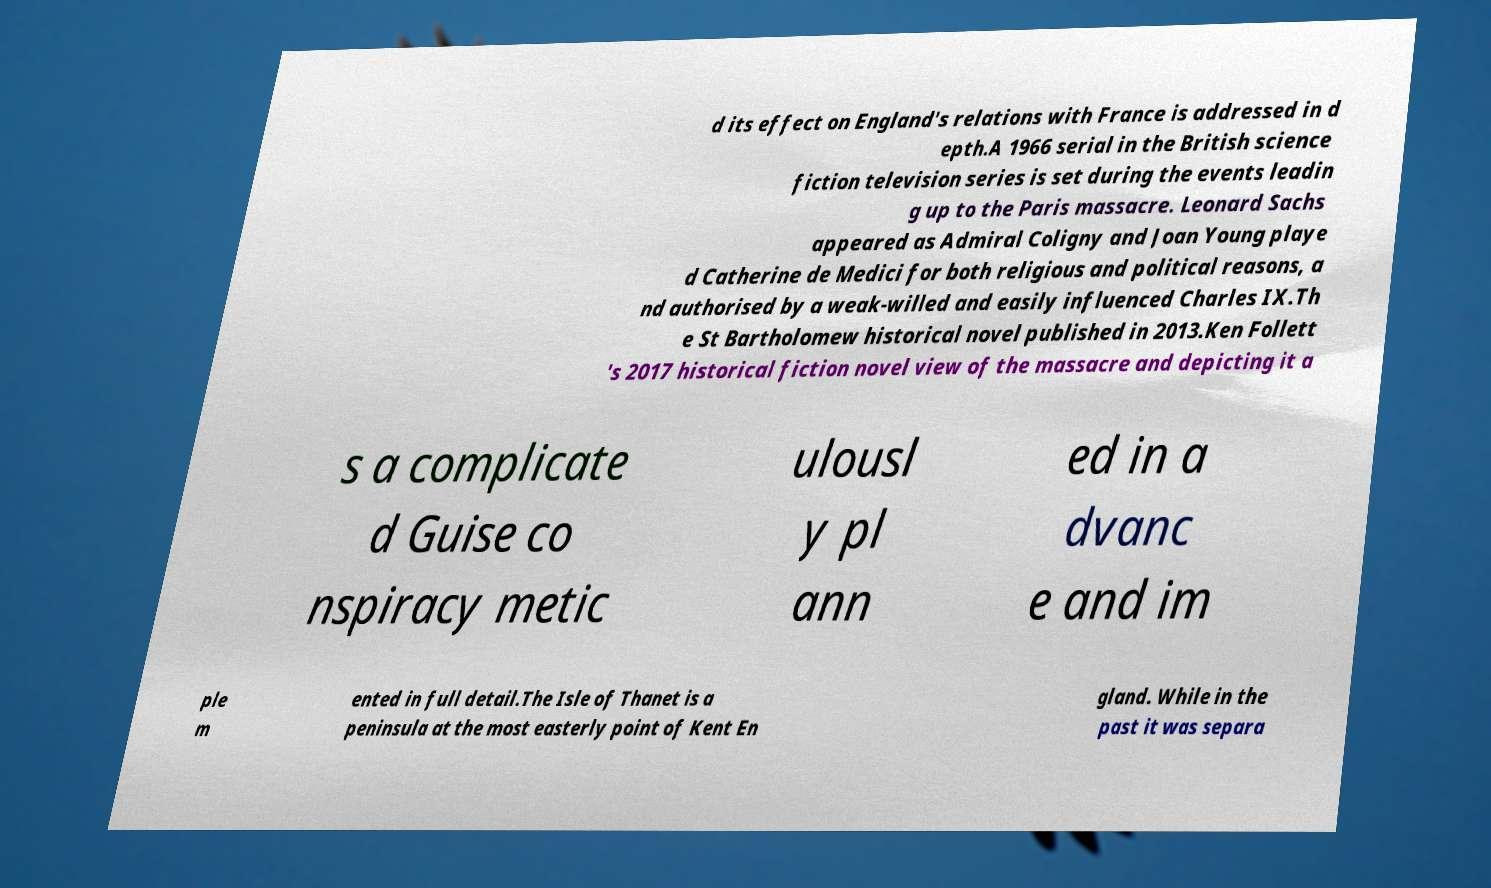There's text embedded in this image that I need extracted. Can you transcribe it verbatim? d its effect on England's relations with France is addressed in d epth.A 1966 serial in the British science fiction television series is set during the events leadin g up to the Paris massacre. Leonard Sachs appeared as Admiral Coligny and Joan Young playe d Catherine de Medici for both religious and political reasons, a nd authorised by a weak-willed and easily influenced Charles IX.Th e St Bartholomew historical novel published in 2013.Ken Follett 's 2017 historical fiction novel view of the massacre and depicting it a s a complicate d Guise co nspiracy metic ulousl y pl ann ed in a dvanc e and im ple m ented in full detail.The Isle of Thanet is a peninsula at the most easterly point of Kent En gland. While in the past it was separa 